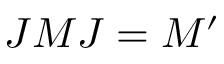Convert formula to latex. <formula><loc_0><loc_0><loc_500><loc_500>J M J = M ^ { \prime }</formula> 